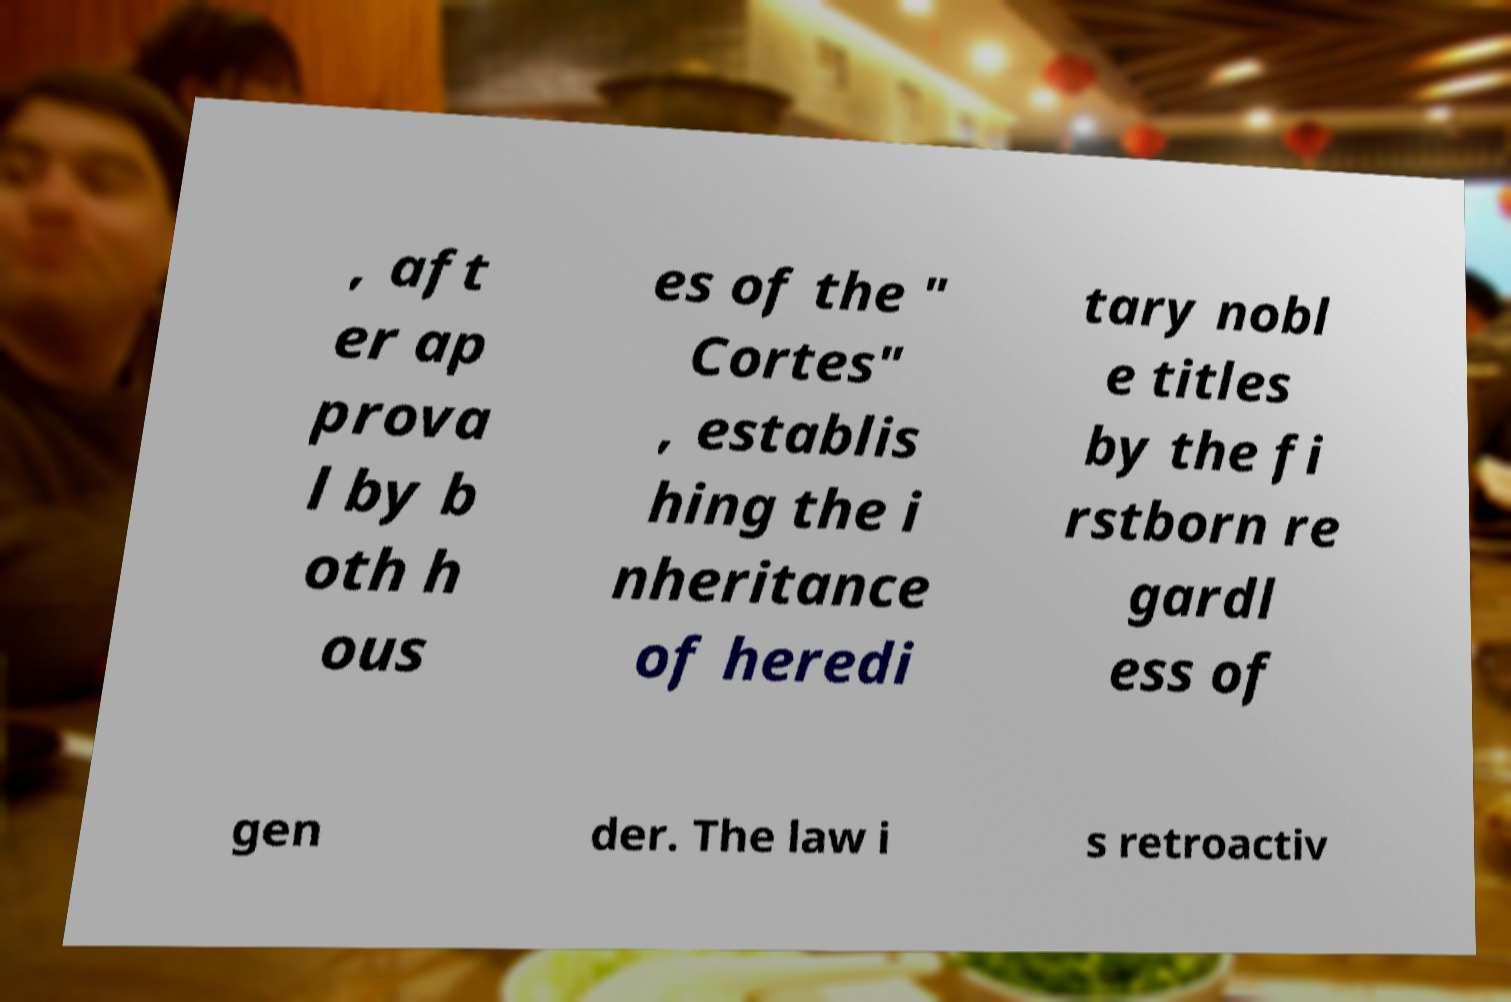I need the written content from this picture converted into text. Can you do that? , aft er ap prova l by b oth h ous es of the " Cortes" , establis hing the i nheritance of heredi tary nobl e titles by the fi rstborn re gardl ess of gen der. The law i s retroactiv 